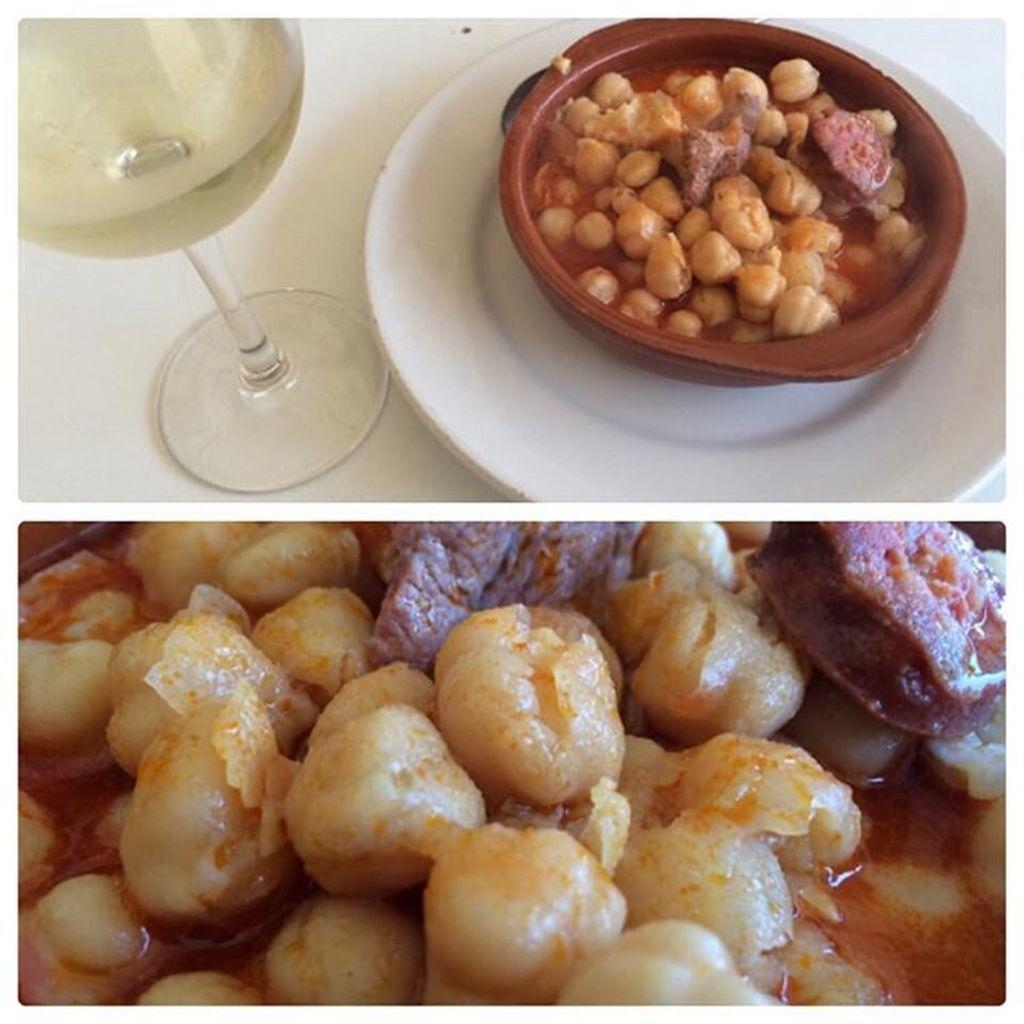What is the main subject of the image? The main subject of the image is a bowl of food items. How are the food items arranged in the image? The food items are on a plate in the image. What other object can be seen on the table in the image? There is a glass on the table in the image. What type of toys are scattered around the food items in the image? There are no toys present in the image; it contains a bowl of food items on a plate and a glass on the table. 